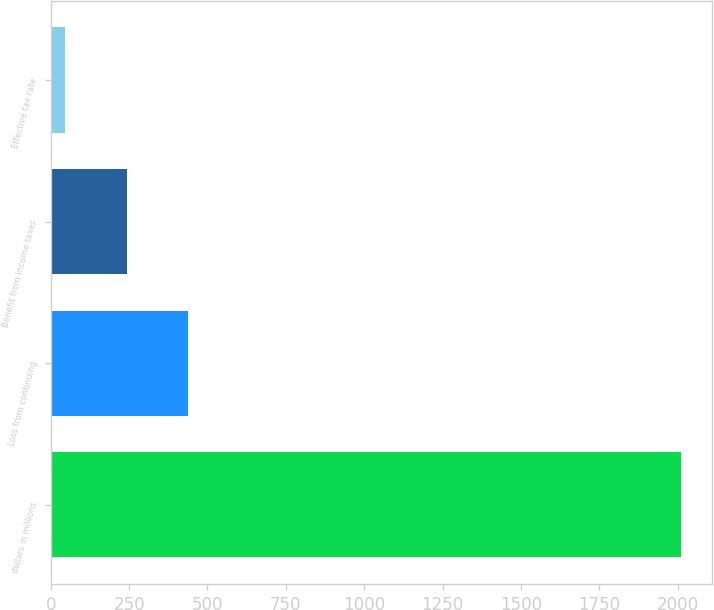<chart> <loc_0><loc_0><loc_500><loc_500><bar_chart><fcel>dollars in millions<fcel>Loss from continuing<fcel>Benefit from income taxes<fcel>Effective tax rate<nl><fcel>2010<fcel>439.28<fcel>242.94<fcel>46.6<nl></chart> 